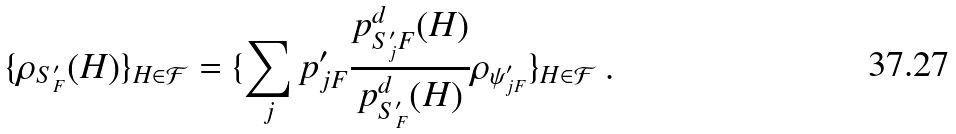Convert formula to latex. <formula><loc_0><loc_0><loc_500><loc_500>\{ \rho _ { S ^ { \prime } _ { F } } ( H ) \} _ { H \in { \mathcal { F } } } = \{ \sum _ { j } p ^ { \prime } _ { j F } \frac { p _ { S ^ { \prime } _ { j } F } ^ { d } ( H ) } { p _ { S ^ { \prime } _ { F } } ^ { d } ( H ) } \rho _ { \psi ^ { \prime } _ { j F } } \} _ { H \in { \mathcal { F } } } \ .</formula> 